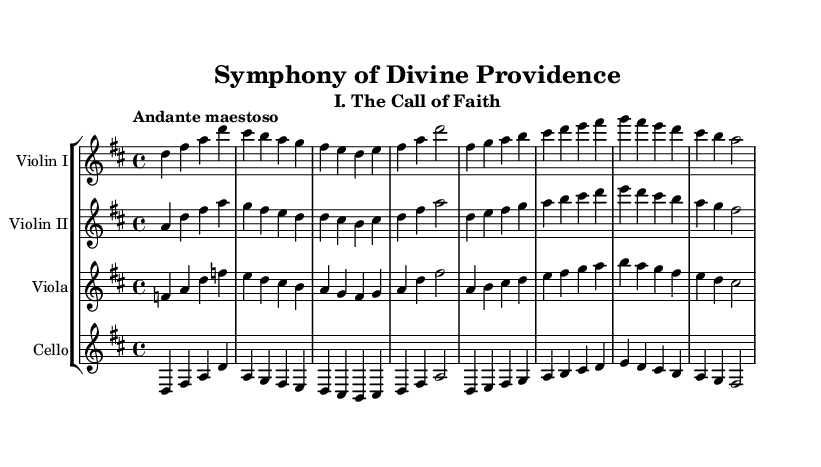What is the key signature of this music? The key signature is indicated by the symbol placed on the staff at the beginning of the piece. Here, there is an F# and a C#, which indicates that the key is D major.
Answer: D major What is the time signature of this music? The time signature is represented by two numbers located at the beginning of the piece. The numbers "4" over "4" indicate that there are four beats in each measure, and the quarter note gets one beat.
Answer: 4/4 What is the tempo marking for this movement? The tempo marking is written above the staff at the beginning of the piece, indicating the speed. It reads "Andante maestoso," which suggests a moderately slow, majestic tempo.
Answer: Andante maestoso Which instruments are included in this score? The instruments are specified in the header and also labeled above each staff. They include Violin I, Violin II, Viola, and Cello.
Answer: Violin I, Violin II, Viola, Cello What is the structure of this movement based on the repeating phrases? By analyzing the music, we can observe that the measure sequences and overall musical phrases reflect a theme and variations structure typical of Romantic music, where the thematic material is stated and then developed.
Answer: Theme and variations How many measures are in the first section of this score? By counting the measures indicated by vertical lines in the score, the first section has a total of eight measures before any significant repetition or variation occurs.
Answer: 8 measures What primary emotion do the dynamics in the score suggest? Dynamics are indicated throughout the score with symbols such as "p" for piano (soft) and "f" for forte (loud), suggesting a mixture of contemplation and exuberance typical of Romantic expressiveness. By analyzing these, one could argue that the overarching emotion is a blend of faith and triumph.
Answer: Faith and triumph 